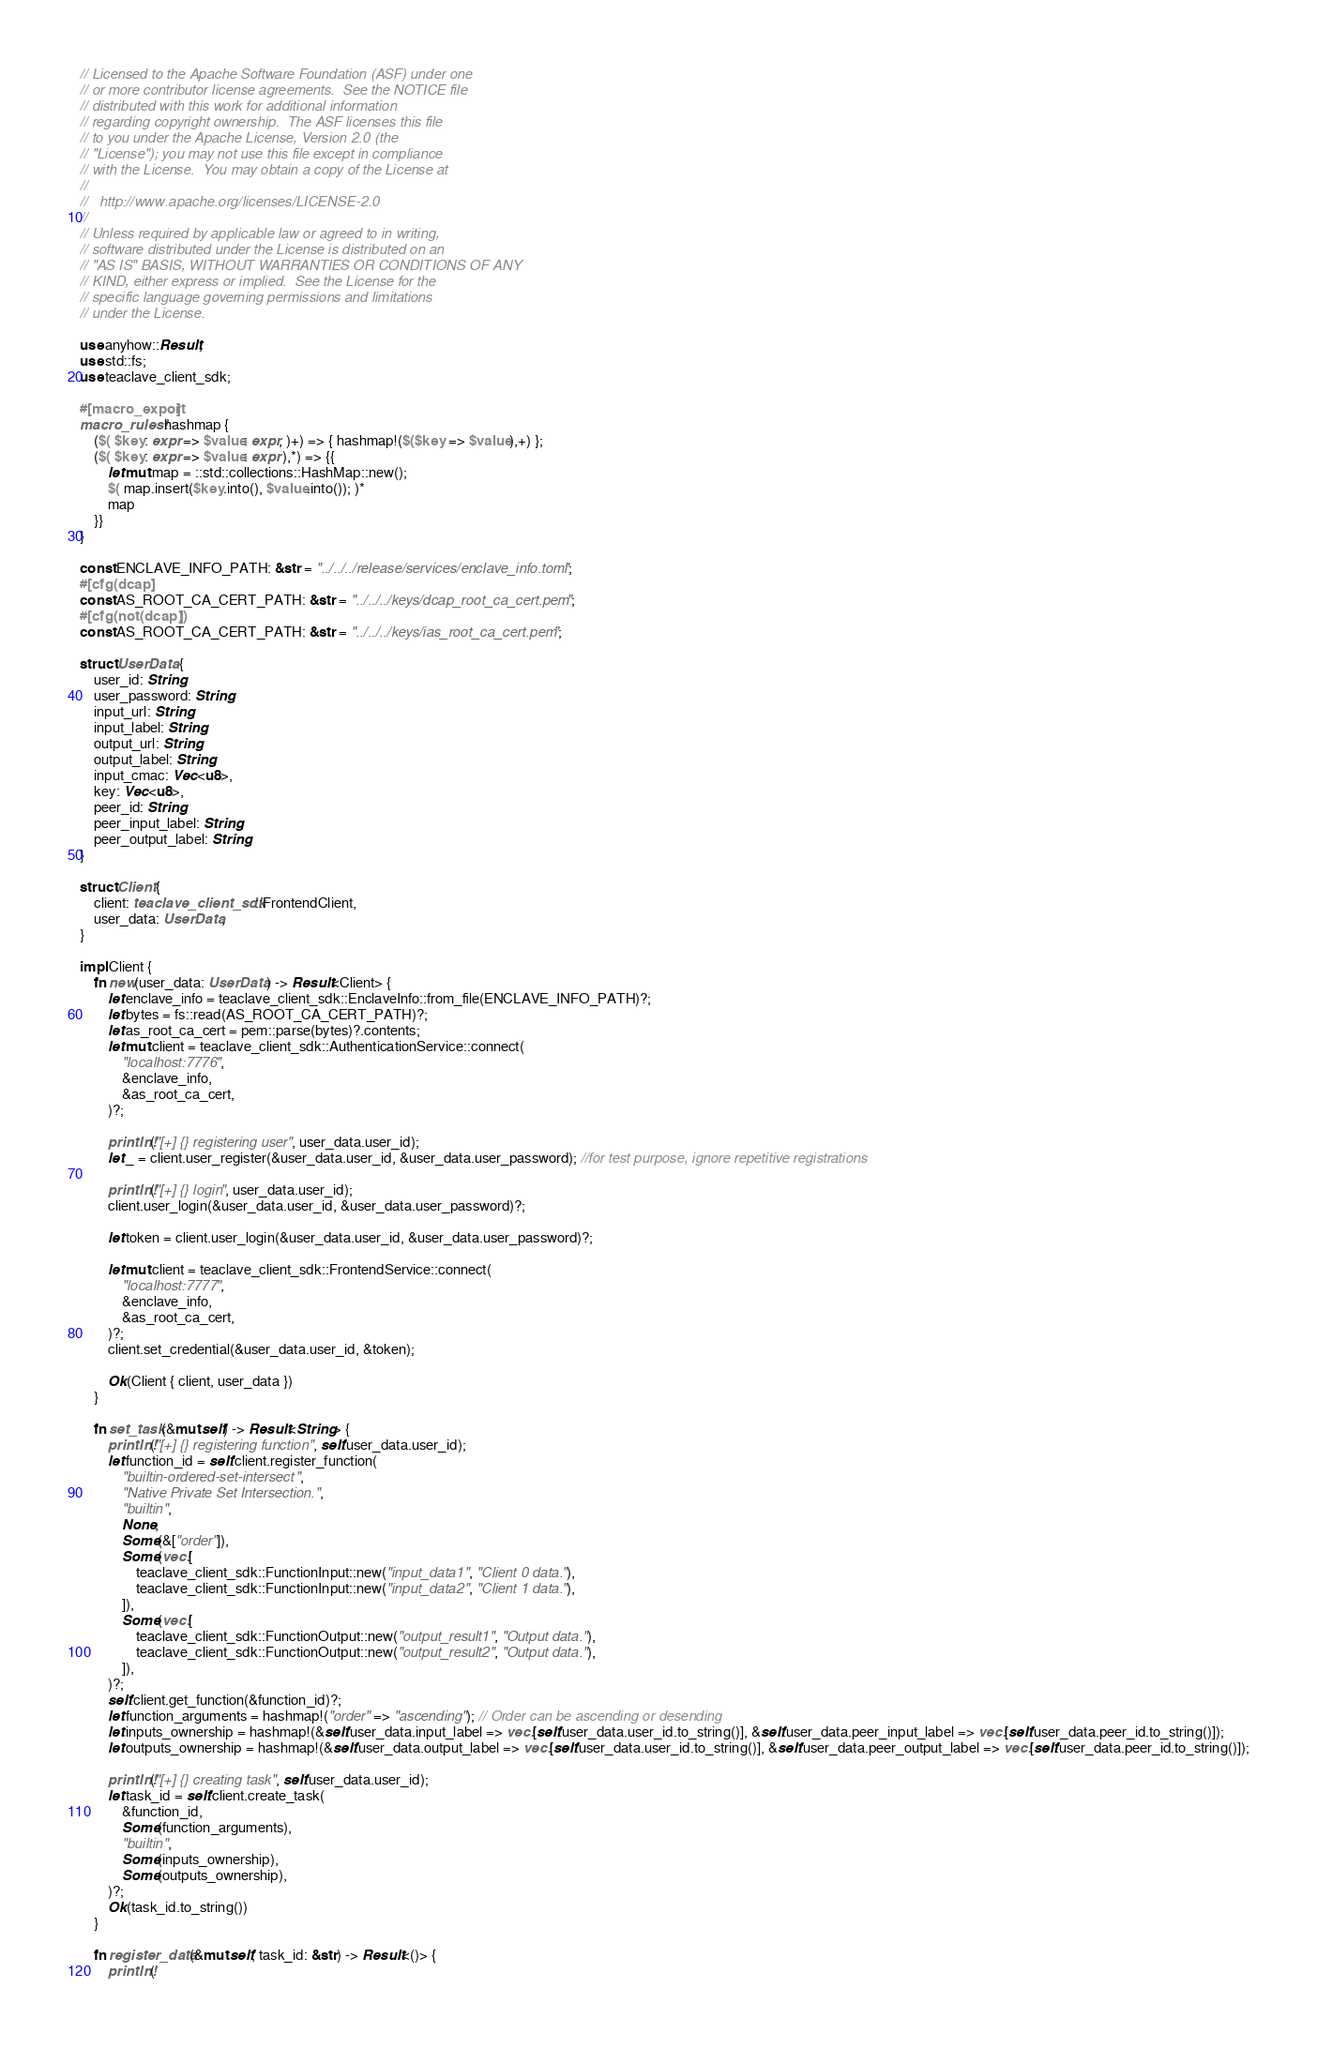<code> <loc_0><loc_0><loc_500><loc_500><_Rust_>// Licensed to the Apache Software Foundation (ASF) under one
// or more contributor license agreements.  See the NOTICE file
// distributed with this work for additional information
// regarding copyright ownership.  The ASF licenses this file
// to you under the Apache License, Version 2.0 (the
// "License"); you may not use this file except in compliance
// with the License.  You may obtain a copy of the License at
//
//   http://www.apache.org/licenses/LICENSE-2.0
//
// Unless required by applicable law or agreed to in writing,
// software distributed under the License is distributed on an
// "AS IS" BASIS, WITHOUT WARRANTIES OR CONDITIONS OF ANY
// KIND, either express or implied.  See the License for the
// specific language governing permissions and limitations
// under the License.

use anyhow::Result;
use std::fs;
use teaclave_client_sdk;

#[macro_export]
macro_rules! hashmap {
    ($( $key: expr => $value: expr, )+) => { hashmap!($($key => $value),+) };
    ($( $key: expr => $value: expr ),*) => {{
        let mut map = ::std::collections::HashMap::new();
        $( map.insert($key.into(), $value.into()); )*
        map
    }}
}

const ENCLAVE_INFO_PATH: &str = "../../../release/services/enclave_info.toml";
#[cfg(dcap)]
const AS_ROOT_CA_CERT_PATH: &str = "../../../keys/dcap_root_ca_cert.pem";
#[cfg(not(dcap))]
const AS_ROOT_CA_CERT_PATH: &str = "../../../keys/ias_root_ca_cert.pem";

struct UserData {
    user_id: String,
    user_password: String,
    input_url: String,
    input_label: String,
    output_url: String,
    output_label: String,
    input_cmac: Vec<u8>,
    key: Vec<u8>,
    peer_id: String,
    peer_input_label: String,
    peer_output_label: String,
}

struct Client {
    client: teaclave_client_sdk::FrontendClient,
    user_data: UserData,
}

impl Client {
    fn new(user_data: UserData) -> Result<Client> {
        let enclave_info = teaclave_client_sdk::EnclaveInfo::from_file(ENCLAVE_INFO_PATH)?;
        let bytes = fs::read(AS_ROOT_CA_CERT_PATH)?;
        let as_root_ca_cert = pem::parse(bytes)?.contents;
        let mut client = teaclave_client_sdk::AuthenticationService::connect(
            "localhost:7776",
            &enclave_info,
            &as_root_ca_cert,
        )?;

        println!("[+] {} registering user", user_data.user_id);
        let _ = client.user_register(&user_data.user_id, &user_data.user_password); //for test purpose, ignore repetitive registrations

        println!("[+] {} login", user_data.user_id);
        client.user_login(&user_data.user_id, &user_data.user_password)?;

        let token = client.user_login(&user_data.user_id, &user_data.user_password)?;

        let mut client = teaclave_client_sdk::FrontendService::connect(
            "localhost:7777",
            &enclave_info,
            &as_root_ca_cert,
        )?;
        client.set_credential(&user_data.user_id, &token);

        Ok(Client { client, user_data })
    }

    fn set_task(&mut self) -> Result<String> {
        println!("[+] {} registering function", self.user_data.user_id);
        let function_id = self.client.register_function(
            "builtin-ordered-set-intersect",
            "Native Private Set Intersection.",
            "builtin",
            None,
            Some(&["order"]),
            Some(vec![
                teaclave_client_sdk::FunctionInput::new("input_data1", "Client 0 data."),
                teaclave_client_sdk::FunctionInput::new("input_data2", "Client 1 data."),
            ]),
            Some(vec![
                teaclave_client_sdk::FunctionOutput::new("output_result1", "Output data."),
                teaclave_client_sdk::FunctionOutput::new("output_result2", "Output data."),
            ]),
        )?;
        self.client.get_function(&function_id)?;
        let function_arguments = hashmap!("order" => "ascending"); // Order can be ascending or desending
        let inputs_ownership = hashmap!(&self.user_data.input_label => vec![self.user_data.user_id.to_string()], &self.user_data.peer_input_label => vec![self.user_data.peer_id.to_string()]);
        let outputs_ownership = hashmap!(&self.user_data.output_label => vec![self.user_data.user_id.to_string()], &self.user_data.peer_output_label => vec![self.user_data.peer_id.to_string()]);

        println!("[+] {} creating task", self.user_data.user_id);
        let task_id = self.client.create_task(
            &function_id,
            Some(function_arguments),
            "builtin",
            Some(inputs_ownership),
            Some(outputs_ownership),
        )?;
        Ok(task_id.to_string())
    }

    fn register_data(&mut self, task_id: &str) -> Result<()> {
        println!(</code> 